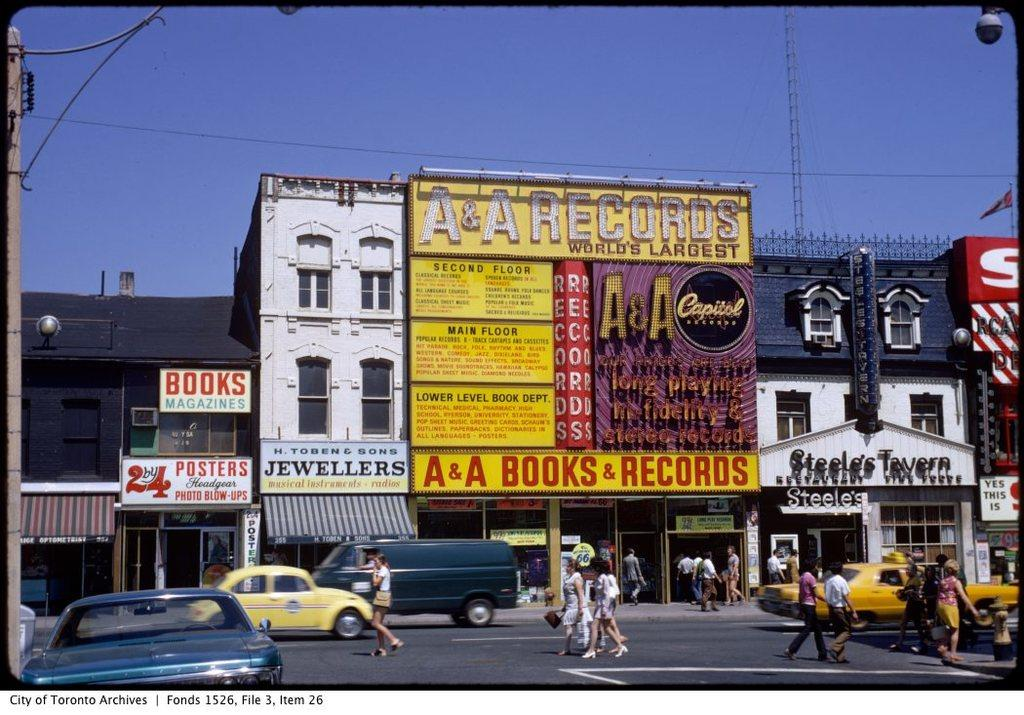What type of structures can be seen in the image? There are buildings in the image. What else can be found on the ground in the image? Vehicles are parked on the ground in the image. Are there any people visible in the image? Yes, there are people standing on the road in the image. What type of pen is being used by the person standing on the road in the image? There is no pen visible in the image, and no person is shown using one. 